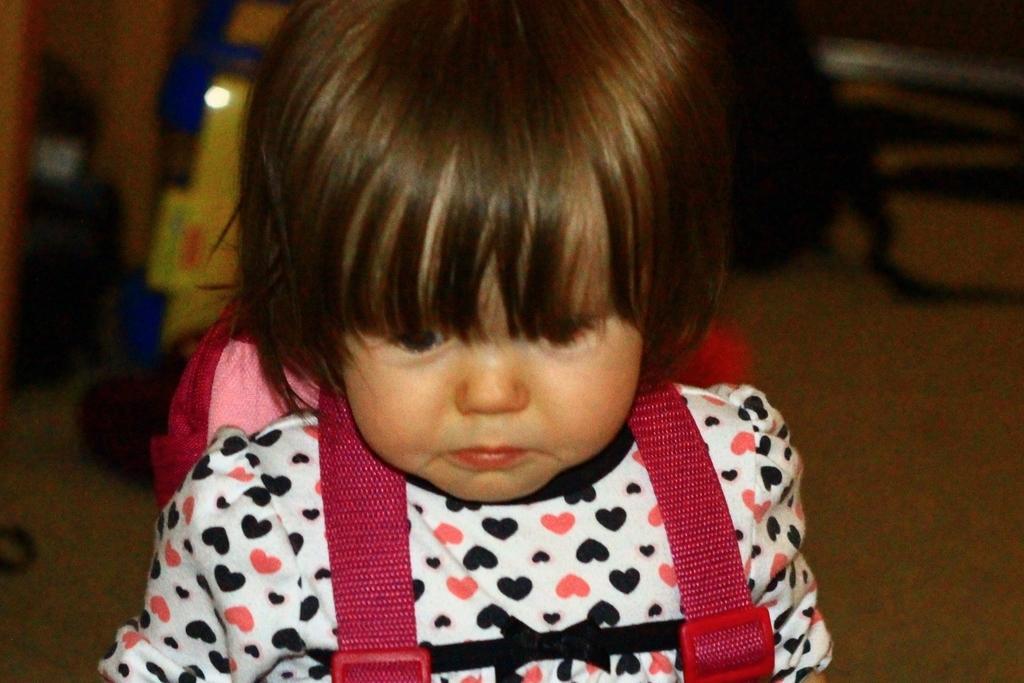Please provide a concise description of this image. There is one kid holding a backpack as we can see in the middle of this image. 